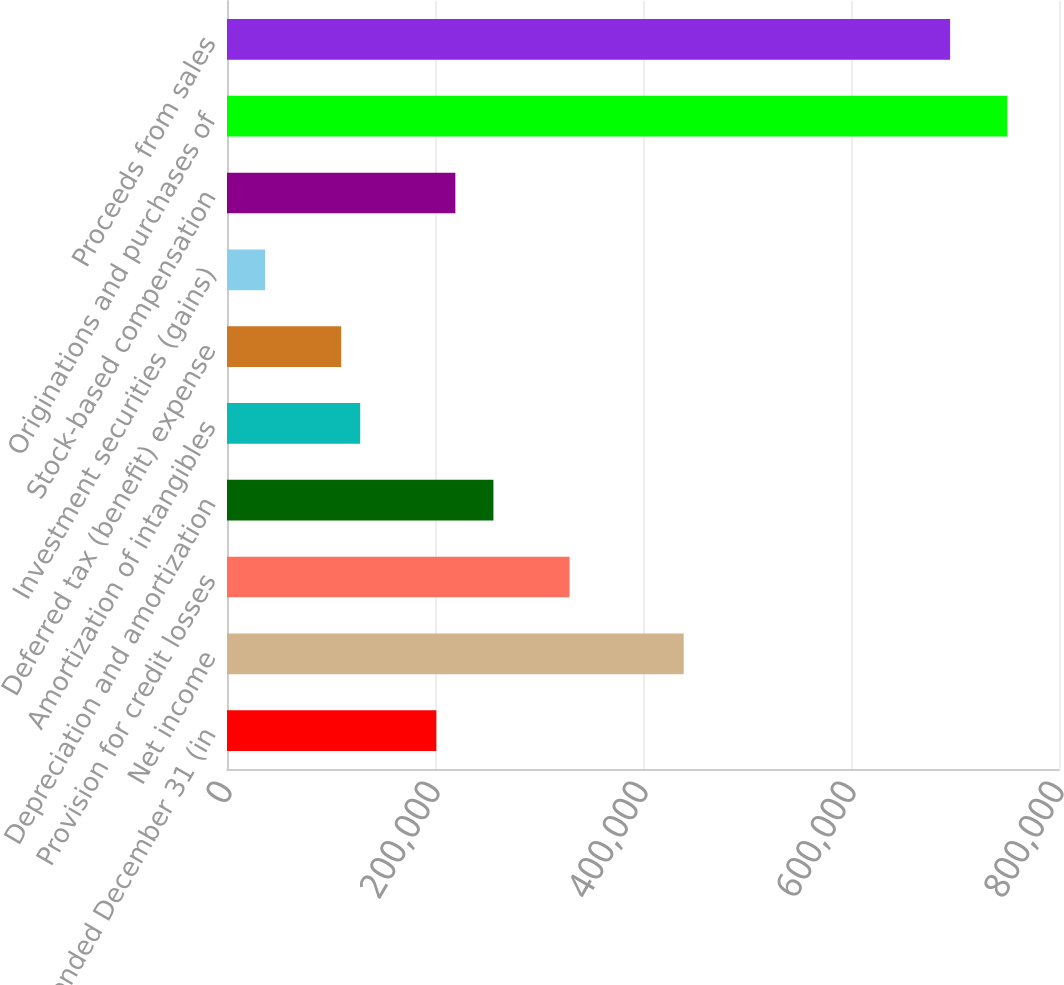Convert chart. <chart><loc_0><loc_0><loc_500><loc_500><bar_chart><fcel>Year ended December 31 (in<fcel>Net income<fcel>Provision for credit losses<fcel>Depreciation and amortization<fcel>Amortization of intangibles<fcel>Deferred tax (benefit) expense<fcel>Investment securities (gains)<fcel>Stock-based compensation<fcel>Originations and purchases of<fcel>Proceeds from sales<nl><fcel>201283<fcel>439147<fcel>329364<fcel>256175<fcel>128094<fcel>109797<fcel>36608.4<fcel>219580<fcel>750199<fcel>695308<nl></chart> 